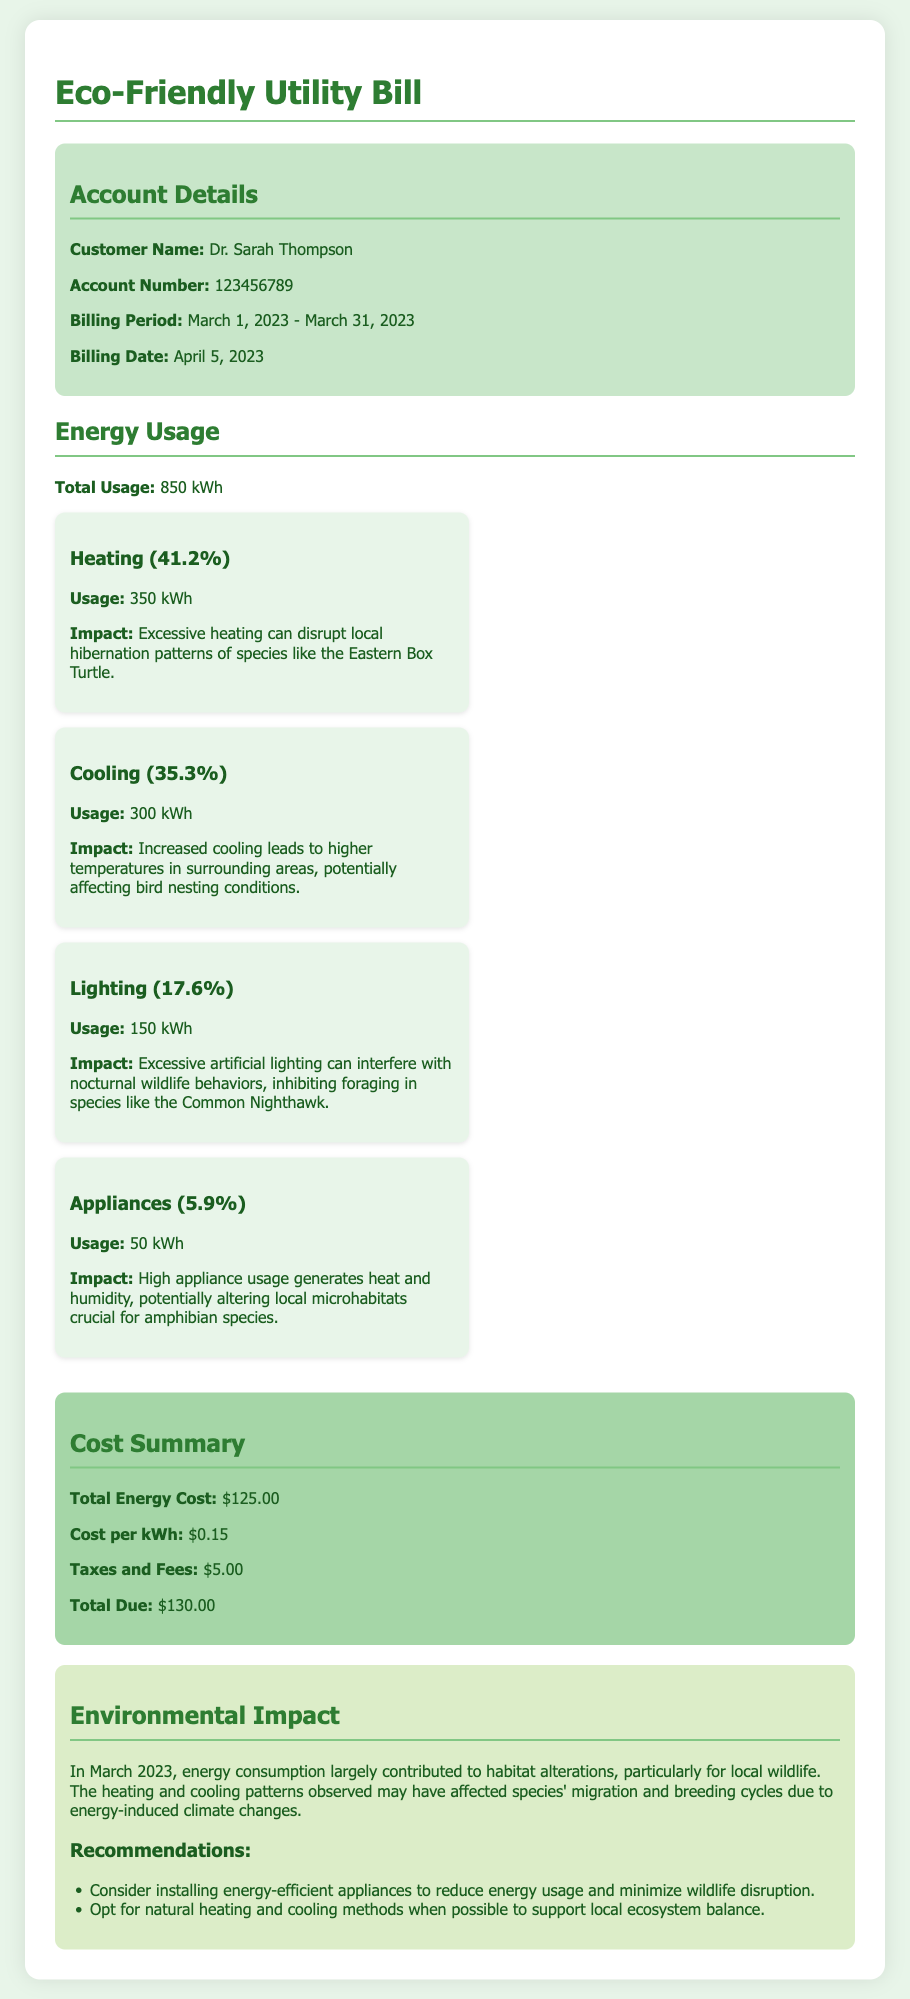what is the total energy usage for March 2023? The total energy usage is explicitly mentioned as 850 kWh.
Answer: 850 kWh who is the customer of this utility bill? The account details section states the customer name is Dr. Sarah Thompson.
Answer: Dr. Sarah Thompson what percentage of total usage is attributed to heating? The breakdown shows that heating accounts for 41.2% of the total energy usage.
Answer: 41.2% what is the total energy cost listed in the document? The cost summary details that the total energy cost is $125.00.
Answer: $125.00 which species' behavior is affected by excessive artificial lighting? The document states that excessive artificial lighting interferes with the foraging of the Common Nighthawk.
Answer: Common Nighthawk how much did the customer spend on taxes and fees? The cost summary outlines that taxes and fees amount to $5.00.
Answer: $5.00 what impact does increased cooling have on local wildlife? It mentions that increased cooling can affect bird nesting conditions.
Answer: Bird nesting conditions what is one recommendation to minimize wildlife disruption? The environmental impact section suggests installing energy-efficient appliances as a recommendation.
Answer: Installing energy-efficient appliances 